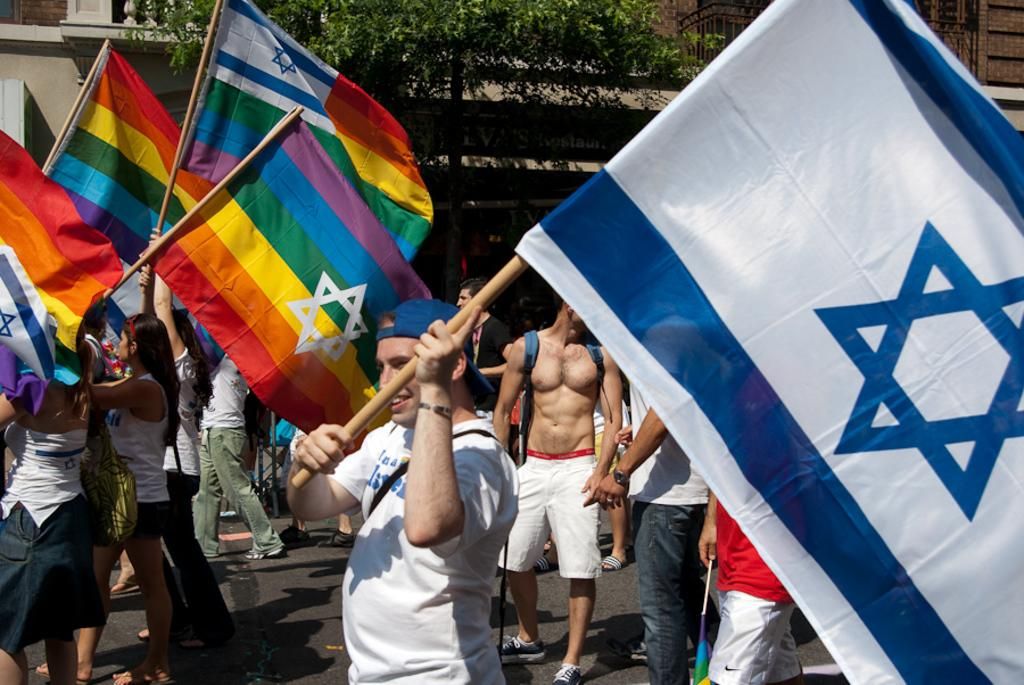What are the people in the image doing? The people in the image are holding flags. Can you describe any accessories the people are wearing? Some people are wearing bags, and a person in the front is wearing a cap. What can be seen in the background of the image? There is a tree and a building in the background of the image. Where is the nest located in the image? There is no nest present in the image. What type of nerve is visible in the image? There is no nerve present in the image. 